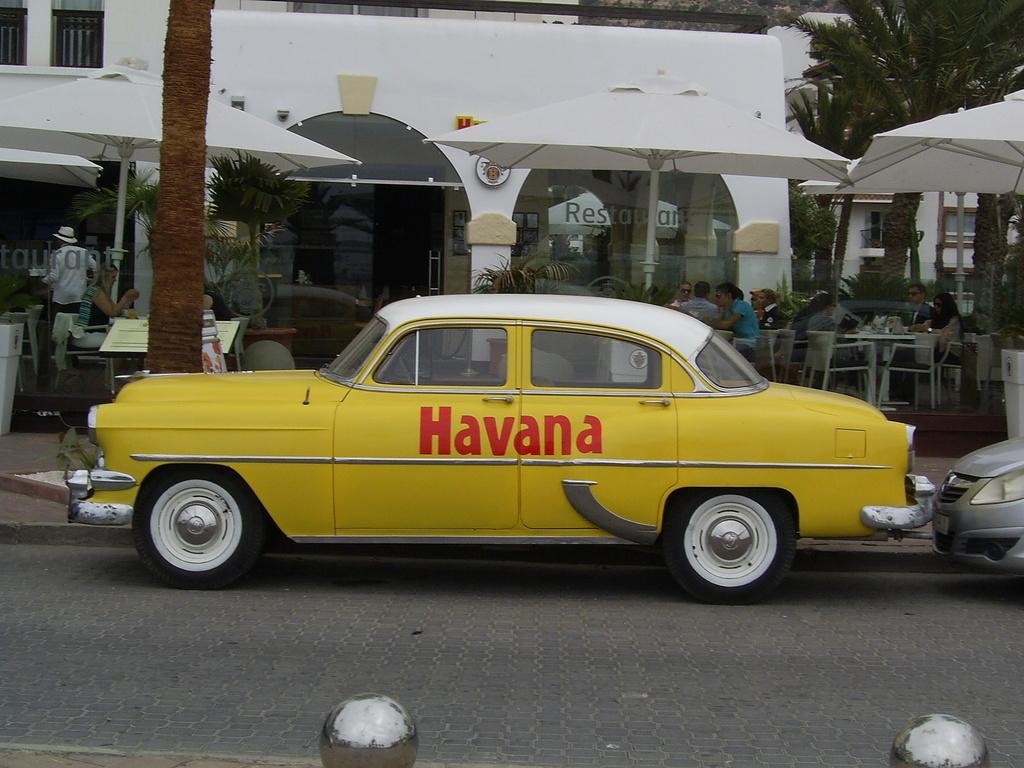<image>
Create a compact narrative representing the image presented. The yellow taxi cab advertising the one and only Havana. 